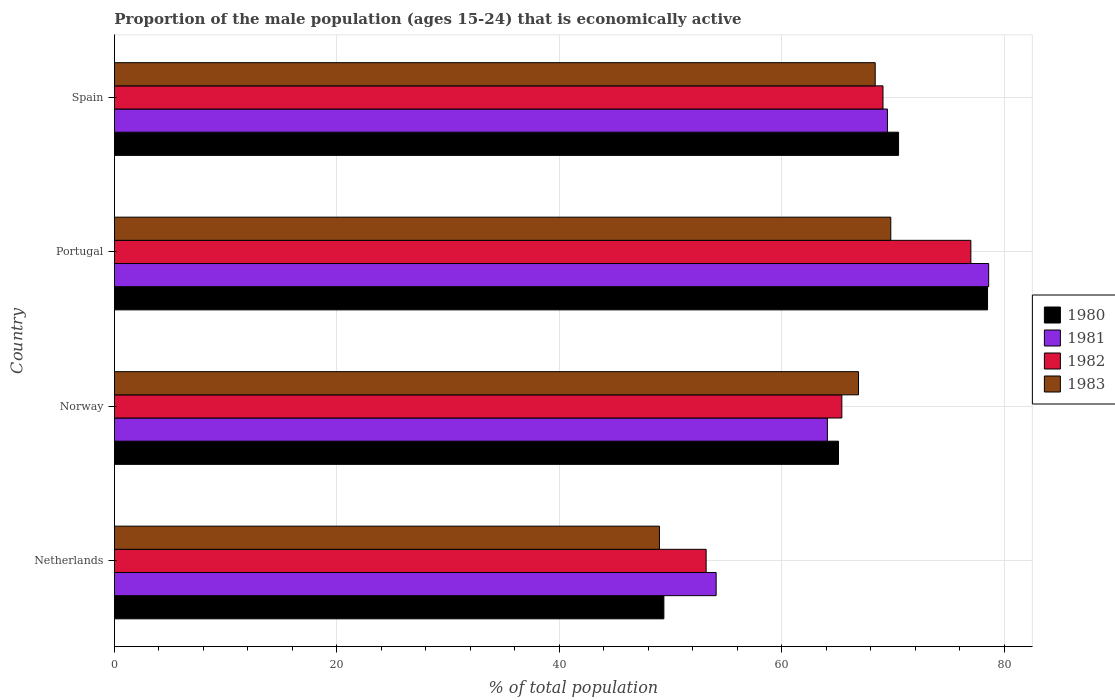Are the number of bars per tick equal to the number of legend labels?
Your answer should be very brief. Yes. How many bars are there on the 1st tick from the top?
Your response must be concise. 4. What is the proportion of the male population that is economically active in 1981 in Netherlands?
Keep it short and to the point. 54.1. Across all countries, what is the maximum proportion of the male population that is economically active in 1980?
Your answer should be very brief. 78.5. Across all countries, what is the minimum proportion of the male population that is economically active in 1982?
Your answer should be very brief. 53.2. In which country was the proportion of the male population that is economically active in 1981 maximum?
Your answer should be compact. Portugal. What is the total proportion of the male population that is economically active in 1980 in the graph?
Your response must be concise. 263.5. What is the difference between the proportion of the male population that is economically active in 1983 in Netherlands and that in Spain?
Give a very brief answer. -19.4. What is the difference between the proportion of the male population that is economically active in 1981 in Netherlands and the proportion of the male population that is economically active in 1982 in Spain?
Offer a terse response. -15. What is the average proportion of the male population that is economically active in 1980 per country?
Provide a succinct answer. 65.87. What is the difference between the proportion of the male population that is economically active in 1983 and proportion of the male population that is economically active in 1980 in Spain?
Provide a short and direct response. -2.1. What is the ratio of the proportion of the male population that is economically active in 1982 in Netherlands to that in Spain?
Keep it short and to the point. 0.77. Is the difference between the proportion of the male population that is economically active in 1983 in Netherlands and Portugal greater than the difference between the proportion of the male population that is economically active in 1980 in Netherlands and Portugal?
Ensure brevity in your answer.  Yes. What is the difference between the highest and the second highest proportion of the male population that is economically active in 1981?
Provide a succinct answer. 9.1. What is the difference between the highest and the lowest proportion of the male population that is economically active in 1982?
Give a very brief answer. 23.8. In how many countries, is the proportion of the male population that is economically active in 1981 greater than the average proportion of the male population that is economically active in 1981 taken over all countries?
Make the answer very short. 2. Is the sum of the proportion of the male population that is economically active in 1983 in Netherlands and Portugal greater than the maximum proportion of the male population that is economically active in 1981 across all countries?
Ensure brevity in your answer.  Yes. Is it the case that in every country, the sum of the proportion of the male population that is economically active in 1983 and proportion of the male population that is economically active in 1981 is greater than the proportion of the male population that is economically active in 1982?
Provide a succinct answer. Yes. How many bars are there?
Provide a short and direct response. 16. Are all the bars in the graph horizontal?
Keep it short and to the point. Yes. How many countries are there in the graph?
Keep it short and to the point. 4. Are the values on the major ticks of X-axis written in scientific E-notation?
Give a very brief answer. No. Does the graph contain any zero values?
Your answer should be compact. No. Does the graph contain grids?
Ensure brevity in your answer.  Yes. Where does the legend appear in the graph?
Offer a terse response. Center right. How many legend labels are there?
Keep it short and to the point. 4. How are the legend labels stacked?
Your answer should be very brief. Vertical. What is the title of the graph?
Keep it short and to the point. Proportion of the male population (ages 15-24) that is economically active. Does "1995" appear as one of the legend labels in the graph?
Ensure brevity in your answer.  No. What is the label or title of the X-axis?
Your answer should be compact. % of total population. What is the % of total population of 1980 in Netherlands?
Offer a very short reply. 49.4. What is the % of total population in 1981 in Netherlands?
Ensure brevity in your answer.  54.1. What is the % of total population of 1982 in Netherlands?
Make the answer very short. 53.2. What is the % of total population of 1980 in Norway?
Ensure brevity in your answer.  65.1. What is the % of total population of 1981 in Norway?
Provide a short and direct response. 64.1. What is the % of total population of 1982 in Norway?
Give a very brief answer. 65.4. What is the % of total population of 1983 in Norway?
Provide a short and direct response. 66.9. What is the % of total population of 1980 in Portugal?
Your response must be concise. 78.5. What is the % of total population of 1981 in Portugal?
Offer a very short reply. 78.6. What is the % of total population in 1982 in Portugal?
Provide a short and direct response. 77. What is the % of total population in 1983 in Portugal?
Keep it short and to the point. 69.8. What is the % of total population of 1980 in Spain?
Keep it short and to the point. 70.5. What is the % of total population in 1981 in Spain?
Your answer should be compact. 69.5. What is the % of total population in 1982 in Spain?
Provide a short and direct response. 69.1. What is the % of total population of 1983 in Spain?
Provide a succinct answer. 68.4. Across all countries, what is the maximum % of total population in 1980?
Provide a short and direct response. 78.5. Across all countries, what is the maximum % of total population of 1981?
Keep it short and to the point. 78.6. Across all countries, what is the maximum % of total population in 1983?
Your response must be concise. 69.8. Across all countries, what is the minimum % of total population in 1980?
Offer a very short reply. 49.4. Across all countries, what is the minimum % of total population of 1981?
Make the answer very short. 54.1. Across all countries, what is the minimum % of total population in 1982?
Your answer should be very brief. 53.2. Across all countries, what is the minimum % of total population of 1983?
Provide a short and direct response. 49. What is the total % of total population of 1980 in the graph?
Provide a short and direct response. 263.5. What is the total % of total population in 1981 in the graph?
Keep it short and to the point. 266.3. What is the total % of total population in 1982 in the graph?
Offer a very short reply. 264.7. What is the total % of total population of 1983 in the graph?
Make the answer very short. 254.1. What is the difference between the % of total population of 1980 in Netherlands and that in Norway?
Provide a succinct answer. -15.7. What is the difference between the % of total population of 1983 in Netherlands and that in Norway?
Your answer should be very brief. -17.9. What is the difference between the % of total population in 1980 in Netherlands and that in Portugal?
Offer a very short reply. -29.1. What is the difference between the % of total population of 1981 in Netherlands and that in Portugal?
Offer a terse response. -24.5. What is the difference between the % of total population of 1982 in Netherlands and that in Portugal?
Your answer should be compact. -23.8. What is the difference between the % of total population in 1983 in Netherlands and that in Portugal?
Give a very brief answer. -20.8. What is the difference between the % of total population in 1980 in Netherlands and that in Spain?
Your answer should be very brief. -21.1. What is the difference between the % of total population in 1981 in Netherlands and that in Spain?
Ensure brevity in your answer.  -15.4. What is the difference between the % of total population of 1982 in Netherlands and that in Spain?
Give a very brief answer. -15.9. What is the difference between the % of total population in 1983 in Netherlands and that in Spain?
Offer a very short reply. -19.4. What is the difference between the % of total population in 1980 in Norway and that in Portugal?
Provide a succinct answer. -13.4. What is the difference between the % of total population in 1981 in Norway and that in Portugal?
Offer a very short reply. -14.5. What is the difference between the % of total population in 1983 in Norway and that in Portugal?
Your response must be concise. -2.9. What is the difference between the % of total population of 1982 in Portugal and that in Spain?
Make the answer very short. 7.9. What is the difference between the % of total population of 1980 in Netherlands and the % of total population of 1981 in Norway?
Offer a very short reply. -14.7. What is the difference between the % of total population of 1980 in Netherlands and the % of total population of 1983 in Norway?
Keep it short and to the point. -17.5. What is the difference between the % of total population of 1982 in Netherlands and the % of total population of 1983 in Norway?
Provide a short and direct response. -13.7. What is the difference between the % of total population in 1980 in Netherlands and the % of total population in 1981 in Portugal?
Offer a very short reply. -29.2. What is the difference between the % of total population of 1980 in Netherlands and the % of total population of 1982 in Portugal?
Your answer should be very brief. -27.6. What is the difference between the % of total population in 1980 in Netherlands and the % of total population in 1983 in Portugal?
Keep it short and to the point. -20.4. What is the difference between the % of total population in 1981 in Netherlands and the % of total population in 1982 in Portugal?
Ensure brevity in your answer.  -22.9. What is the difference between the % of total population of 1981 in Netherlands and the % of total population of 1983 in Portugal?
Provide a succinct answer. -15.7. What is the difference between the % of total population of 1982 in Netherlands and the % of total population of 1983 in Portugal?
Provide a short and direct response. -16.6. What is the difference between the % of total population of 1980 in Netherlands and the % of total population of 1981 in Spain?
Your answer should be compact. -20.1. What is the difference between the % of total population in 1980 in Netherlands and the % of total population in 1982 in Spain?
Your answer should be compact. -19.7. What is the difference between the % of total population of 1981 in Netherlands and the % of total population of 1983 in Spain?
Your answer should be very brief. -14.3. What is the difference between the % of total population of 1982 in Netherlands and the % of total population of 1983 in Spain?
Your answer should be very brief. -15.2. What is the difference between the % of total population of 1980 in Norway and the % of total population of 1982 in Portugal?
Your answer should be very brief. -11.9. What is the difference between the % of total population in 1981 in Norway and the % of total population in 1982 in Portugal?
Offer a very short reply. -12.9. What is the difference between the % of total population of 1982 in Norway and the % of total population of 1983 in Portugal?
Ensure brevity in your answer.  -4.4. What is the difference between the % of total population of 1980 in Portugal and the % of total population of 1981 in Spain?
Ensure brevity in your answer.  9. What is the difference between the % of total population in 1980 in Portugal and the % of total population in 1982 in Spain?
Ensure brevity in your answer.  9.4. What is the difference between the % of total population in 1981 in Portugal and the % of total population in 1983 in Spain?
Make the answer very short. 10.2. What is the difference between the % of total population of 1982 in Portugal and the % of total population of 1983 in Spain?
Your response must be concise. 8.6. What is the average % of total population of 1980 per country?
Give a very brief answer. 65.88. What is the average % of total population of 1981 per country?
Make the answer very short. 66.58. What is the average % of total population in 1982 per country?
Offer a very short reply. 66.17. What is the average % of total population of 1983 per country?
Give a very brief answer. 63.52. What is the difference between the % of total population of 1980 and % of total population of 1983 in Netherlands?
Ensure brevity in your answer.  0.4. What is the difference between the % of total population in 1981 and % of total population in 1982 in Netherlands?
Ensure brevity in your answer.  0.9. What is the difference between the % of total population in 1981 and % of total population in 1983 in Netherlands?
Your answer should be very brief. 5.1. What is the difference between the % of total population in 1982 and % of total population in 1983 in Netherlands?
Your answer should be very brief. 4.2. What is the difference between the % of total population of 1980 and % of total population of 1981 in Norway?
Ensure brevity in your answer.  1. What is the difference between the % of total population in 1981 and % of total population in 1982 in Norway?
Ensure brevity in your answer.  -1.3. What is the difference between the % of total population of 1980 and % of total population of 1981 in Portugal?
Make the answer very short. -0.1. What is the difference between the % of total population of 1980 and % of total population of 1983 in Portugal?
Make the answer very short. 8.7. What is the difference between the % of total population of 1981 and % of total population of 1982 in Portugal?
Offer a terse response. 1.6. What is the difference between the % of total population of 1981 and % of total population of 1983 in Portugal?
Provide a succinct answer. 8.8. What is the difference between the % of total population in 1980 and % of total population in 1982 in Spain?
Your answer should be very brief. 1.4. What is the ratio of the % of total population in 1980 in Netherlands to that in Norway?
Give a very brief answer. 0.76. What is the ratio of the % of total population of 1981 in Netherlands to that in Norway?
Give a very brief answer. 0.84. What is the ratio of the % of total population of 1982 in Netherlands to that in Norway?
Keep it short and to the point. 0.81. What is the ratio of the % of total population in 1983 in Netherlands to that in Norway?
Make the answer very short. 0.73. What is the ratio of the % of total population of 1980 in Netherlands to that in Portugal?
Offer a very short reply. 0.63. What is the ratio of the % of total population of 1981 in Netherlands to that in Portugal?
Make the answer very short. 0.69. What is the ratio of the % of total population in 1982 in Netherlands to that in Portugal?
Ensure brevity in your answer.  0.69. What is the ratio of the % of total population of 1983 in Netherlands to that in Portugal?
Offer a terse response. 0.7. What is the ratio of the % of total population of 1980 in Netherlands to that in Spain?
Offer a very short reply. 0.7. What is the ratio of the % of total population in 1981 in Netherlands to that in Spain?
Offer a very short reply. 0.78. What is the ratio of the % of total population of 1982 in Netherlands to that in Spain?
Your answer should be very brief. 0.77. What is the ratio of the % of total population of 1983 in Netherlands to that in Spain?
Provide a succinct answer. 0.72. What is the ratio of the % of total population of 1980 in Norway to that in Portugal?
Make the answer very short. 0.83. What is the ratio of the % of total population in 1981 in Norway to that in Portugal?
Make the answer very short. 0.82. What is the ratio of the % of total population of 1982 in Norway to that in Portugal?
Offer a terse response. 0.85. What is the ratio of the % of total population in 1983 in Norway to that in Portugal?
Keep it short and to the point. 0.96. What is the ratio of the % of total population of 1980 in Norway to that in Spain?
Your answer should be compact. 0.92. What is the ratio of the % of total population in 1981 in Norway to that in Spain?
Give a very brief answer. 0.92. What is the ratio of the % of total population of 1982 in Norway to that in Spain?
Your answer should be very brief. 0.95. What is the ratio of the % of total population of 1983 in Norway to that in Spain?
Offer a terse response. 0.98. What is the ratio of the % of total population of 1980 in Portugal to that in Spain?
Make the answer very short. 1.11. What is the ratio of the % of total population of 1981 in Portugal to that in Spain?
Keep it short and to the point. 1.13. What is the ratio of the % of total population in 1982 in Portugal to that in Spain?
Offer a very short reply. 1.11. What is the ratio of the % of total population in 1983 in Portugal to that in Spain?
Give a very brief answer. 1.02. What is the difference between the highest and the second highest % of total population in 1982?
Your response must be concise. 7.9. What is the difference between the highest and the second highest % of total population of 1983?
Your answer should be very brief. 1.4. What is the difference between the highest and the lowest % of total population in 1980?
Keep it short and to the point. 29.1. What is the difference between the highest and the lowest % of total population in 1982?
Offer a terse response. 23.8. What is the difference between the highest and the lowest % of total population in 1983?
Give a very brief answer. 20.8. 